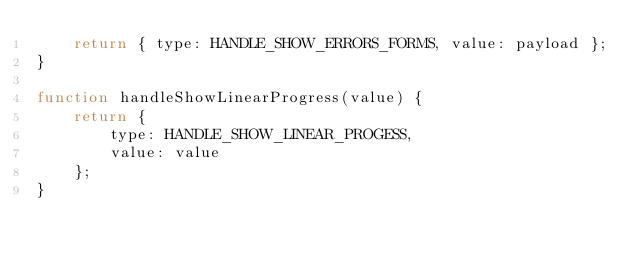Convert code to text. <code><loc_0><loc_0><loc_500><loc_500><_JavaScript_>    return { type: HANDLE_SHOW_ERRORS_FORMS, value: payload };
}

function handleShowLinearProgress(value) {
    return {
        type: HANDLE_SHOW_LINEAR_PROGESS,
        value: value
    };
}
</code> 